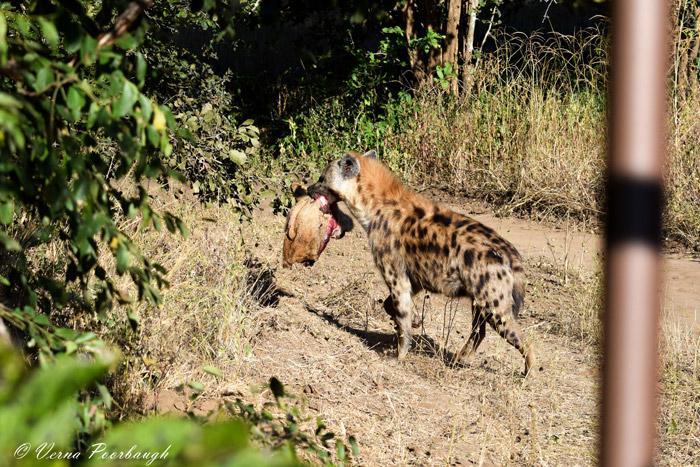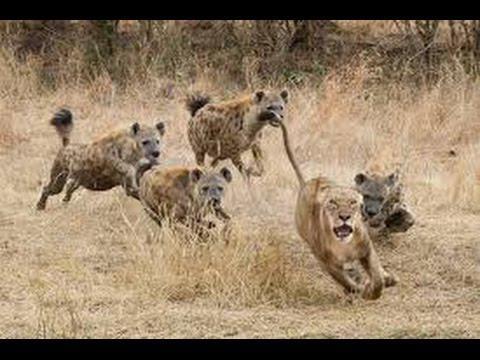The first image is the image on the left, the second image is the image on the right. Assess this claim about the two images: "The left image contains one lion.". Correct or not? Answer yes or no. No. The first image is the image on the left, the second image is the image on the right. Analyze the images presented: Is the assertion "In at least one image there is a lion eating a hyena by the neck." valid? Answer yes or no. No. 